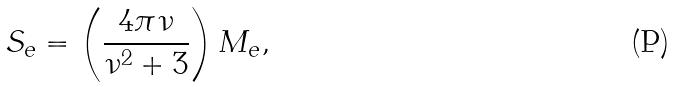Convert formula to latex. <formula><loc_0><loc_0><loc_500><loc_500>S _ { e } = \left ( \frac { 4 \pi \nu } { \nu ^ { 2 } + 3 } \right ) M _ { e } ,</formula> 